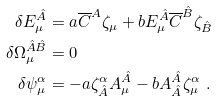<formula> <loc_0><loc_0><loc_500><loc_500>\delta E _ { \mu } ^ { \hat { A } } & = a \overline { C } ^ { A } \zeta _ { \mu } + b E _ { \mu } ^ { \hat { A } } \overline { C } ^ { \hat { B } } \zeta _ { \hat { B } } \\ \delta \Omega ^ { \hat { A } \hat { B } } _ { \mu } & = 0 \\ \delta \psi _ { \mu } ^ { \alpha } & = - a \zeta ^ { \alpha } _ { \hat { A } } A ^ { \hat { A } } _ { \mu } - b A ^ { \hat { A } } _ { \hat { A } } \zeta _ { \mu } ^ { \alpha } \ .</formula> 